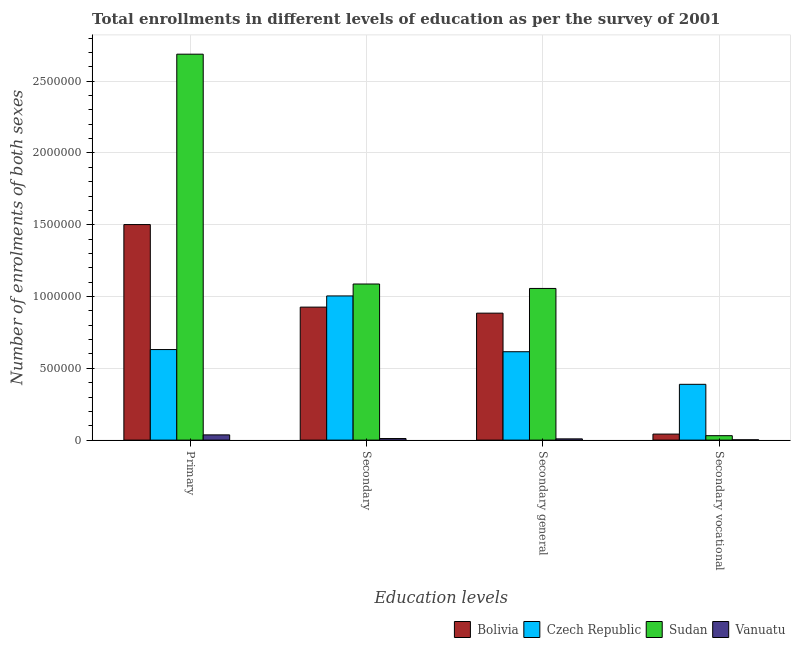How many groups of bars are there?
Ensure brevity in your answer.  4. Are the number of bars per tick equal to the number of legend labels?
Offer a terse response. Yes. Are the number of bars on each tick of the X-axis equal?
Provide a short and direct response. Yes. How many bars are there on the 3rd tick from the left?
Your response must be concise. 4. What is the label of the 2nd group of bars from the left?
Ensure brevity in your answer.  Secondary. What is the number of enrolments in secondary vocational education in Czech Republic?
Keep it short and to the point. 3.89e+05. Across all countries, what is the maximum number of enrolments in secondary general education?
Provide a succinct answer. 1.06e+06. Across all countries, what is the minimum number of enrolments in primary education?
Make the answer very short. 3.65e+04. In which country was the number of enrolments in primary education maximum?
Provide a succinct answer. Sudan. In which country was the number of enrolments in secondary general education minimum?
Provide a succinct answer. Vanuatu. What is the total number of enrolments in secondary vocational education in the graph?
Provide a succinct answer. 4.64e+05. What is the difference between the number of enrolments in primary education in Bolivia and that in Czech Republic?
Keep it short and to the point. 8.70e+05. What is the difference between the number of enrolments in primary education in Bolivia and the number of enrolments in secondary education in Czech Republic?
Your response must be concise. 4.97e+05. What is the average number of enrolments in secondary general education per country?
Your answer should be very brief. 6.41e+05. What is the difference between the number of enrolments in secondary vocational education and number of enrolments in secondary education in Bolivia?
Keep it short and to the point. -8.84e+05. In how many countries, is the number of enrolments in secondary general education greater than 500000 ?
Offer a very short reply. 3. What is the ratio of the number of enrolments in secondary education in Czech Republic to that in Sudan?
Provide a succinct answer. 0.92. Is the number of enrolments in secondary general education in Bolivia less than that in Sudan?
Offer a terse response. Yes. What is the difference between the highest and the second highest number of enrolments in secondary vocational education?
Your answer should be very brief. 3.47e+05. What is the difference between the highest and the lowest number of enrolments in secondary vocational education?
Keep it short and to the point. 3.86e+05. In how many countries, is the number of enrolments in secondary vocational education greater than the average number of enrolments in secondary vocational education taken over all countries?
Your answer should be compact. 1. Is the sum of the number of enrolments in primary education in Bolivia and Vanuatu greater than the maximum number of enrolments in secondary general education across all countries?
Offer a very short reply. Yes. What does the 3rd bar from the right in Secondary general represents?
Your response must be concise. Czech Republic. Is it the case that in every country, the sum of the number of enrolments in primary education and number of enrolments in secondary education is greater than the number of enrolments in secondary general education?
Give a very brief answer. Yes. Are all the bars in the graph horizontal?
Your response must be concise. No. What is the difference between two consecutive major ticks on the Y-axis?
Your answer should be very brief. 5.00e+05. Are the values on the major ticks of Y-axis written in scientific E-notation?
Provide a succinct answer. No. Does the graph contain grids?
Give a very brief answer. Yes. Where does the legend appear in the graph?
Give a very brief answer. Bottom right. How are the legend labels stacked?
Ensure brevity in your answer.  Horizontal. What is the title of the graph?
Offer a terse response. Total enrollments in different levels of education as per the survey of 2001. Does "Macao" appear as one of the legend labels in the graph?
Give a very brief answer. No. What is the label or title of the X-axis?
Make the answer very short. Education levels. What is the label or title of the Y-axis?
Ensure brevity in your answer.  Number of enrolments of both sexes. What is the Number of enrolments of both sexes of Bolivia in Primary?
Provide a succinct answer. 1.50e+06. What is the Number of enrolments of both sexes in Czech Republic in Primary?
Ensure brevity in your answer.  6.31e+05. What is the Number of enrolments of both sexes of Sudan in Primary?
Ensure brevity in your answer.  2.69e+06. What is the Number of enrolments of both sexes of Vanuatu in Primary?
Ensure brevity in your answer.  3.65e+04. What is the Number of enrolments of both sexes of Bolivia in Secondary?
Offer a very short reply. 9.26e+05. What is the Number of enrolments of both sexes in Czech Republic in Secondary?
Give a very brief answer. 1.00e+06. What is the Number of enrolments of both sexes in Sudan in Secondary?
Offer a terse response. 1.09e+06. What is the Number of enrolments of both sexes of Vanuatu in Secondary?
Keep it short and to the point. 1.09e+04. What is the Number of enrolments of both sexes of Bolivia in Secondary general?
Give a very brief answer. 8.84e+05. What is the Number of enrolments of both sexes in Czech Republic in Secondary general?
Ensure brevity in your answer.  6.16e+05. What is the Number of enrolments of both sexes of Sudan in Secondary general?
Offer a terse response. 1.06e+06. What is the Number of enrolments of both sexes in Vanuatu in Secondary general?
Offer a very short reply. 8746. What is the Number of enrolments of both sexes in Bolivia in Secondary vocational?
Offer a terse response. 4.20e+04. What is the Number of enrolments of both sexes in Czech Republic in Secondary vocational?
Your answer should be compact. 3.89e+05. What is the Number of enrolments of both sexes in Sudan in Secondary vocational?
Keep it short and to the point. 3.09e+04. What is the Number of enrolments of both sexes of Vanuatu in Secondary vocational?
Your answer should be very brief. 2188. Across all Education levels, what is the maximum Number of enrolments of both sexes in Bolivia?
Give a very brief answer. 1.50e+06. Across all Education levels, what is the maximum Number of enrolments of both sexes in Czech Republic?
Provide a succinct answer. 1.00e+06. Across all Education levels, what is the maximum Number of enrolments of both sexes of Sudan?
Provide a short and direct response. 2.69e+06. Across all Education levels, what is the maximum Number of enrolments of both sexes of Vanuatu?
Offer a terse response. 3.65e+04. Across all Education levels, what is the minimum Number of enrolments of both sexes in Bolivia?
Ensure brevity in your answer.  4.20e+04. Across all Education levels, what is the minimum Number of enrolments of both sexes in Czech Republic?
Your answer should be compact. 3.89e+05. Across all Education levels, what is the minimum Number of enrolments of both sexes in Sudan?
Your answer should be very brief. 3.09e+04. Across all Education levels, what is the minimum Number of enrolments of both sexes in Vanuatu?
Keep it short and to the point. 2188. What is the total Number of enrolments of both sexes of Bolivia in the graph?
Keep it short and to the point. 3.35e+06. What is the total Number of enrolments of both sexes of Czech Republic in the graph?
Keep it short and to the point. 2.64e+06. What is the total Number of enrolments of both sexes in Sudan in the graph?
Keep it short and to the point. 4.86e+06. What is the total Number of enrolments of both sexes in Vanuatu in the graph?
Provide a short and direct response. 5.84e+04. What is the difference between the Number of enrolments of both sexes in Bolivia in Primary and that in Secondary?
Give a very brief answer. 5.75e+05. What is the difference between the Number of enrolments of both sexes in Czech Republic in Primary and that in Secondary?
Offer a terse response. -3.73e+05. What is the difference between the Number of enrolments of both sexes of Sudan in Primary and that in Secondary?
Make the answer very short. 1.60e+06. What is the difference between the Number of enrolments of both sexes in Vanuatu in Primary and that in Secondary?
Offer a terse response. 2.55e+04. What is the difference between the Number of enrolments of both sexes of Bolivia in Primary and that in Secondary general?
Your answer should be compact. 6.17e+05. What is the difference between the Number of enrolments of both sexes of Czech Republic in Primary and that in Secondary general?
Provide a short and direct response. 1.51e+04. What is the difference between the Number of enrolments of both sexes of Sudan in Primary and that in Secondary general?
Provide a succinct answer. 1.63e+06. What is the difference between the Number of enrolments of both sexes of Vanuatu in Primary and that in Secondary general?
Ensure brevity in your answer.  2.77e+04. What is the difference between the Number of enrolments of both sexes of Bolivia in Primary and that in Secondary vocational?
Ensure brevity in your answer.  1.46e+06. What is the difference between the Number of enrolments of both sexes in Czech Republic in Primary and that in Secondary vocational?
Keep it short and to the point. 2.42e+05. What is the difference between the Number of enrolments of both sexes of Sudan in Primary and that in Secondary vocational?
Keep it short and to the point. 2.66e+06. What is the difference between the Number of enrolments of both sexes of Vanuatu in Primary and that in Secondary vocational?
Your answer should be compact. 3.43e+04. What is the difference between the Number of enrolments of both sexes in Bolivia in Secondary and that in Secondary general?
Offer a terse response. 4.20e+04. What is the difference between the Number of enrolments of both sexes in Czech Republic in Secondary and that in Secondary general?
Make the answer very short. 3.89e+05. What is the difference between the Number of enrolments of both sexes in Sudan in Secondary and that in Secondary general?
Your response must be concise. 3.09e+04. What is the difference between the Number of enrolments of both sexes of Vanuatu in Secondary and that in Secondary general?
Make the answer very short. 2188. What is the difference between the Number of enrolments of both sexes in Bolivia in Secondary and that in Secondary vocational?
Provide a short and direct response. 8.84e+05. What is the difference between the Number of enrolments of both sexes in Czech Republic in Secondary and that in Secondary vocational?
Make the answer very short. 6.16e+05. What is the difference between the Number of enrolments of both sexes of Sudan in Secondary and that in Secondary vocational?
Your answer should be compact. 1.06e+06. What is the difference between the Number of enrolments of both sexes in Vanuatu in Secondary and that in Secondary vocational?
Your answer should be very brief. 8746. What is the difference between the Number of enrolments of both sexes of Bolivia in Secondary general and that in Secondary vocational?
Your response must be concise. 8.42e+05. What is the difference between the Number of enrolments of both sexes of Czech Republic in Secondary general and that in Secondary vocational?
Keep it short and to the point. 2.27e+05. What is the difference between the Number of enrolments of both sexes in Sudan in Secondary general and that in Secondary vocational?
Offer a terse response. 1.03e+06. What is the difference between the Number of enrolments of both sexes of Vanuatu in Secondary general and that in Secondary vocational?
Provide a short and direct response. 6558. What is the difference between the Number of enrolments of both sexes of Bolivia in Primary and the Number of enrolments of both sexes of Czech Republic in Secondary?
Your response must be concise. 4.97e+05. What is the difference between the Number of enrolments of both sexes in Bolivia in Primary and the Number of enrolments of both sexes in Sudan in Secondary?
Give a very brief answer. 4.14e+05. What is the difference between the Number of enrolments of both sexes of Bolivia in Primary and the Number of enrolments of both sexes of Vanuatu in Secondary?
Offer a terse response. 1.49e+06. What is the difference between the Number of enrolments of both sexes of Czech Republic in Primary and the Number of enrolments of both sexes of Sudan in Secondary?
Ensure brevity in your answer.  -4.56e+05. What is the difference between the Number of enrolments of both sexes in Czech Republic in Primary and the Number of enrolments of both sexes in Vanuatu in Secondary?
Offer a very short reply. 6.20e+05. What is the difference between the Number of enrolments of both sexes of Sudan in Primary and the Number of enrolments of both sexes of Vanuatu in Secondary?
Make the answer very short. 2.68e+06. What is the difference between the Number of enrolments of both sexes in Bolivia in Primary and the Number of enrolments of both sexes in Czech Republic in Secondary general?
Offer a terse response. 8.85e+05. What is the difference between the Number of enrolments of both sexes of Bolivia in Primary and the Number of enrolments of both sexes of Sudan in Secondary general?
Provide a succinct answer. 4.45e+05. What is the difference between the Number of enrolments of both sexes of Bolivia in Primary and the Number of enrolments of both sexes of Vanuatu in Secondary general?
Keep it short and to the point. 1.49e+06. What is the difference between the Number of enrolments of both sexes in Czech Republic in Primary and the Number of enrolments of both sexes in Sudan in Secondary general?
Provide a short and direct response. -4.26e+05. What is the difference between the Number of enrolments of both sexes of Czech Republic in Primary and the Number of enrolments of both sexes of Vanuatu in Secondary general?
Provide a short and direct response. 6.22e+05. What is the difference between the Number of enrolments of both sexes in Sudan in Primary and the Number of enrolments of both sexes in Vanuatu in Secondary general?
Your answer should be very brief. 2.68e+06. What is the difference between the Number of enrolments of both sexes of Bolivia in Primary and the Number of enrolments of both sexes of Czech Republic in Secondary vocational?
Give a very brief answer. 1.11e+06. What is the difference between the Number of enrolments of both sexes of Bolivia in Primary and the Number of enrolments of both sexes of Sudan in Secondary vocational?
Offer a terse response. 1.47e+06. What is the difference between the Number of enrolments of both sexes in Bolivia in Primary and the Number of enrolments of both sexes in Vanuatu in Secondary vocational?
Keep it short and to the point. 1.50e+06. What is the difference between the Number of enrolments of both sexes in Czech Republic in Primary and the Number of enrolments of both sexes in Sudan in Secondary vocational?
Make the answer very short. 6.00e+05. What is the difference between the Number of enrolments of both sexes of Czech Republic in Primary and the Number of enrolments of both sexes of Vanuatu in Secondary vocational?
Provide a succinct answer. 6.28e+05. What is the difference between the Number of enrolments of both sexes in Sudan in Primary and the Number of enrolments of both sexes in Vanuatu in Secondary vocational?
Ensure brevity in your answer.  2.69e+06. What is the difference between the Number of enrolments of both sexes of Bolivia in Secondary and the Number of enrolments of both sexes of Czech Republic in Secondary general?
Keep it short and to the point. 3.11e+05. What is the difference between the Number of enrolments of both sexes in Bolivia in Secondary and the Number of enrolments of both sexes in Sudan in Secondary general?
Keep it short and to the point. -1.30e+05. What is the difference between the Number of enrolments of both sexes in Bolivia in Secondary and the Number of enrolments of both sexes in Vanuatu in Secondary general?
Make the answer very short. 9.17e+05. What is the difference between the Number of enrolments of both sexes of Czech Republic in Secondary and the Number of enrolments of both sexes of Sudan in Secondary general?
Make the answer very short. -5.21e+04. What is the difference between the Number of enrolments of both sexes in Czech Republic in Secondary and the Number of enrolments of both sexes in Vanuatu in Secondary general?
Make the answer very short. 9.95e+05. What is the difference between the Number of enrolments of both sexes of Sudan in Secondary and the Number of enrolments of both sexes of Vanuatu in Secondary general?
Make the answer very short. 1.08e+06. What is the difference between the Number of enrolments of both sexes in Bolivia in Secondary and the Number of enrolments of both sexes in Czech Republic in Secondary vocational?
Keep it short and to the point. 5.38e+05. What is the difference between the Number of enrolments of both sexes of Bolivia in Secondary and the Number of enrolments of both sexes of Sudan in Secondary vocational?
Ensure brevity in your answer.  8.95e+05. What is the difference between the Number of enrolments of both sexes of Bolivia in Secondary and the Number of enrolments of both sexes of Vanuatu in Secondary vocational?
Provide a short and direct response. 9.24e+05. What is the difference between the Number of enrolments of both sexes of Czech Republic in Secondary and the Number of enrolments of both sexes of Sudan in Secondary vocational?
Offer a terse response. 9.73e+05. What is the difference between the Number of enrolments of both sexes of Czech Republic in Secondary and the Number of enrolments of both sexes of Vanuatu in Secondary vocational?
Your response must be concise. 1.00e+06. What is the difference between the Number of enrolments of both sexes of Sudan in Secondary and the Number of enrolments of both sexes of Vanuatu in Secondary vocational?
Give a very brief answer. 1.08e+06. What is the difference between the Number of enrolments of both sexes in Bolivia in Secondary general and the Number of enrolments of both sexes in Czech Republic in Secondary vocational?
Ensure brevity in your answer.  4.96e+05. What is the difference between the Number of enrolments of both sexes in Bolivia in Secondary general and the Number of enrolments of both sexes in Sudan in Secondary vocational?
Ensure brevity in your answer.  8.53e+05. What is the difference between the Number of enrolments of both sexes in Bolivia in Secondary general and the Number of enrolments of both sexes in Vanuatu in Secondary vocational?
Ensure brevity in your answer.  8.82e+05. What is the difference between the Number of enrolments of both sexes in Czech Republic in Secondary general and the Number of enrolments of both sexes in Sudan in Secondary vocational?
Your answer should be compact. 5.85e+05. What is the difference between the Number of enrolments of both sexes in Czech Republic in Secondary general and the Number of enrolments of both sexes in Vanuatu in Secondary vocational?
Make the answer very short. 6.13e+05. What is the difference between the Number of enrolments of both sexes in Sudan in Secondary general and the Number of enrolments of both sexes in Vanuatu in Secondary vocational?
Make the answer very short. 1.05e+06. What is the average Number of enrolments of both sexes in Bolivia per Education levels?
Your answer should be compact. 8.38e+05. What is the average Number of enrolments of both sexes in Czech Republic per Education levels?
Provide a short and direct response. 6.60e+05. What is the average Number of enrolments of both sexes of Sudan per Education levels?
Offer a very short reply. 1.22e+06. What is the average Number of enrolments of both sexes of Vanuatu per Education levels?
Offer a very short reply. 1.46e+04. What is the difference between the Number of enrolments of both sexes of Bolivia and Number of enrolments of both sexes of Czech Republic in Primary?
Offer a very short reply. 8.70e+05. What is the difference between the Number of enrolments of both sexes in Bolivia and Number of enrolments of both sexes in Sudan in Primary?
Give a very brief answer. -1.19e+06. What is the difference between the Number of enrolments of both sexes in Bolivia and Number of enrolments of both sexes in Vanuatu in Primary?
Provide a short and direct response. 1.46e+06. What is the difference between the Number of enrolments of both sexes in Czech Republic and Number of enrolments of both sexes in Sudan in Primary?
Provide a short and direct response. -2.06e+06. What is the difference between the Number of enrolments of both sexes of Czech Republic and Number of enrolments of both sexes of Vanuatu in Primary?
Keep it short and to the point. 5.94e+05. What is the difference between the Number of enrolments of both sexes of Sudan and Number of enrolments of both sexes of Vanuatu in Primary?
Give a very brief answer. 2.65e+06. What is the difference between the Number of enrolments of both sexes of Bolivia and Number of enrolments of both sexes of Czech Republic in Secondary?
Your answer should be very brief. -7.79e+04. What is the difference between the Number of enrolments of both sexes in Bolivia and Number of enrolments of both sexes in Sudan in Secondary?
Keep it short and to the point. -1.61e+05. What is the difference between the Number of enrolments of both sexes of Bolivia and Number of enrolments of both sexes of Vanuatu in Secondary?
Your response must be concise. 9.15e+05. What is the difference between the Number of enrolments of both sexes of Czech Republic and Number of enrolments of both sexes of Sudan in Secondary?
Keep it short and to the point. -8.30e+04. What is the difference between the Number of enrolments of both sexes in Czech Republic and Number of enrolments of both sexes in Vanuatu in Secondary?
Ensure brevity in your answer.  9.93e+05. What is the difference between the Number of enrolments of both sexes in Sudan and Number of enrolments of both sexes in Vanuatu in Secondary?
Keep it short and to the point. 1.08e+06. What is the difference between the Number of enrolments of both sexes of Bolivia and Number of enrolments of both sexes of Czech Republic in Secondary general?
Give a very brief answer. 2.69e+05. What is the difference between the Number of enrolments of both sexes of Bolivia and Number of enrolments of both sexes of Sudan in Secondary general?
Make the answer very short. -1.72e+05. What is the difference between the Number of enrolments of both sexes of Bolivia and Number of enrolments of both sexes of Vanuatu in Secondary general?
Your answer should be compact. 8.75e+05. What is the difference between the Number of enrolments of both sexes in Czech Republic and Number of enrolments of both sexes in Sudan in Secondary general?
Keep it short and to the point. -4.41e+05. What is the difference between the Number of enrolments of both sexes of Czech Republic and Number of enrolments of both sexes of Vanuatu in Secondary general?
Provide a succinct answer. 6.07e+05. What is the difference between the Number of enrolments of both sexes in Sudan and Number of enrolments of both sexes in Vanuatu in Secondary general?
Your answer should be compact. 1.05e+06. What is the difference between the Number of enrolments of both sexes in Bolivia and Number of enrolments of both sexes in Czech Republic in Secondary vocational?
Keep it short and to the point. -3.47e+05. What is the difference between the Number of enrolments of both sexes of Bolivia and Number of enrolments of both sexes of Sudan in Secondary vocational?
Provide a short and direct response. 1.11e+04. What is the difference between the Number of enrolments of both sexes of Bolivia and Number of enrolments of both sexes of Vanuatu in Secondary vocational?
Ensure brevity in your answer.  3.98e+04. What is the difference between the Number of enrolments of both sexes of Czech Republic and Number of enrolments of both sexes of Sudan in Secondary vocational?
Offer a terse response. 3.58e+05. What is the difference between the Number of enrolments of both sexes of Czech Republic and Number of enrolments of both sexes of Vanuatu in Secondary vocational?
Offer a terse response. 3.86e+05. What is the difference between the Number of enrolments of both sexes of Sudan and Number of enrolments of both sexes of Vanuatu in Secondary vocational?
Ensure brevity in your answer.  2.87e+04. What is the ratio of the Number of enrolments of both sexes of Bolivia in Primary to that in Secondary?
Provide a succinct answer. 1.62. What is the ratio of the Number of enrolments of both sexes in Czech Republic in Primary to that in Secondary?
Make the answer very short. 0.63. What is the ratio of the Number of enrolments of both sexes of Sudan in Primary to that in Secondary?
Provide a short and direct response. 2.47. What is the ratio of the Number of enrolments of both sexes of Vanuatu in Primary to that in Secondary?
Ensure brevity in your answer.  3.34. What is the ratio of the Number of enrolments of both sexes of Bolivia in Primary to that in Secondary general?
Provide a succinct answer. 1.7. What is the ratio of the Number of enrolments of both sexes of Czech Republic in Primary to that in Secondary general?
Provide a short and direct response. 1.02. What is the ratio of the Number of enrolments of both sexes in Sudan in Primary to that in Secondary general?
Offer a terse response. 2.54. What is the ratio of the Number of enrolments of both sexes in Vanuatu in Primary to that in Secondary general?
Make the answer very short. 4.17. What is the ratio of the Number of enrolments of both sexes of Bolivia in Primary to that in Secondary vocational?
Your response must be concise. 35.75. What is the ratio of the Number of enrolments of both sexes of Czech Republic in Primary to that in Secondary vocational?
Your answer should be compact. 1.62. What is the ratio of the Number of enrolments of both sexes of Sudan in Primary to that in Secondary vocational?
Your response must be concise. 87.03. What is the ratio of the Number of enrolments of both sexes in Vanuatu in Primary to that in Secondary vocational?
Your answer should be compact. 16.67. What is the ratio of the Number of enrolments of both sexes in Bolivia in Secondary to that in Secondary general?
Provide a short and direct response. 1.05. What is the ratio of the Number of enrolments of both sexes of Czech Republic in Secondary to that in Secondary general?
Your answer should be compact. 1.63. What is the ratio of the Number of enrolments of both sexes of Sudan in Secondary to that in Secondary general?
Offer a terse response. 1.03. What is the ratio of the Number of enrolments of both sexes of Vanuatu in Secondary to that in Secondary general?
Keep it short and to the point. 1.25. What is the ratio of the Number of enrolments of both sexes in Bolivia in Secondary to that in Secondary vocational?
Provide a short and direct response. 22.06. What is the ratio of the Number of enrolments of both sexes of Czech Republic in Secondary to that in Secondary vocational?
Ensure brevity in your answer.  2.58. What is the ratio of the Number of enrolments of both sexes of Sudan in Secondary to that in Secondary vocational?
Ensure brevity in your answer.  35.2. What is the ratio of the Number of enrolments of both sexes in Vanuatu in Secondary to that in Secondary vocational?
Provide a short and direct response. 5. What is the ratio of the Number of enrolments of both sexes of Bolivia in Secondary general to that in Secondary vocational?
Ensure brevity in your answer.  21.06. What is the ratio of the Number of enrolments of both sexes in Czech Republic in Secondary general to that in Secondary vocational?
Keep it short and to the point. 1.58. What is the ratio of the Number of enrolments of both sexes of Sudan in Secondary general to that in Secondary vocational?
Ensure brevity in your answer.  34.2. What is the ratio of the Number of enrolments of both sexes in Vanuatu in Secondary general to that in Secondary vocational?
Your answer should be very brief. 4. What is the difference between the highest and the second highest Number of enrolments of both sexes in Bolivia?
Provide a succinct answer. 5.75e+05. What is the difference between the highest and the second highest Number of enrolments of both sexes in Czech Republic?
Keep it short and to the point. 3.73e+05. What is the difference between the highest and the second highest Number of enrolments of both sexes of Sudan?
Make the answer very short. 1.60e+06. What is the difference between the highest and the second highest Number of enrolments of both sexes of Vanuatu?
Your response must be concise. 2.55e+04. What is the difference between the highest and the lowest Number of enrolments of both sexes in Bolivia?
Offer a very short reply. 1.46e+06. What is the difference between the highest and the lowest Number of enrolments of both sexes in Czech Republic?
Offer a terse response. 6.16e+05. What is the difference between the highest and the lowest Number of enrolments of both sexes of Sudan?
Provide a short and direct response. 2.66e+06. What is the difference between the highest and the lowest Number of enrolments of both sexes in Vanuatu?
Your answer should be very brief. 3.43e+04. 